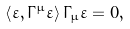<formula> <loc_0><loc_0><loc_500><loc_500>\left < \varepsilon , \Gamma ^ { \mu } \varepsilon \right > \Gamma _ { \mu } \varepsilon = 0 ,</formula> 